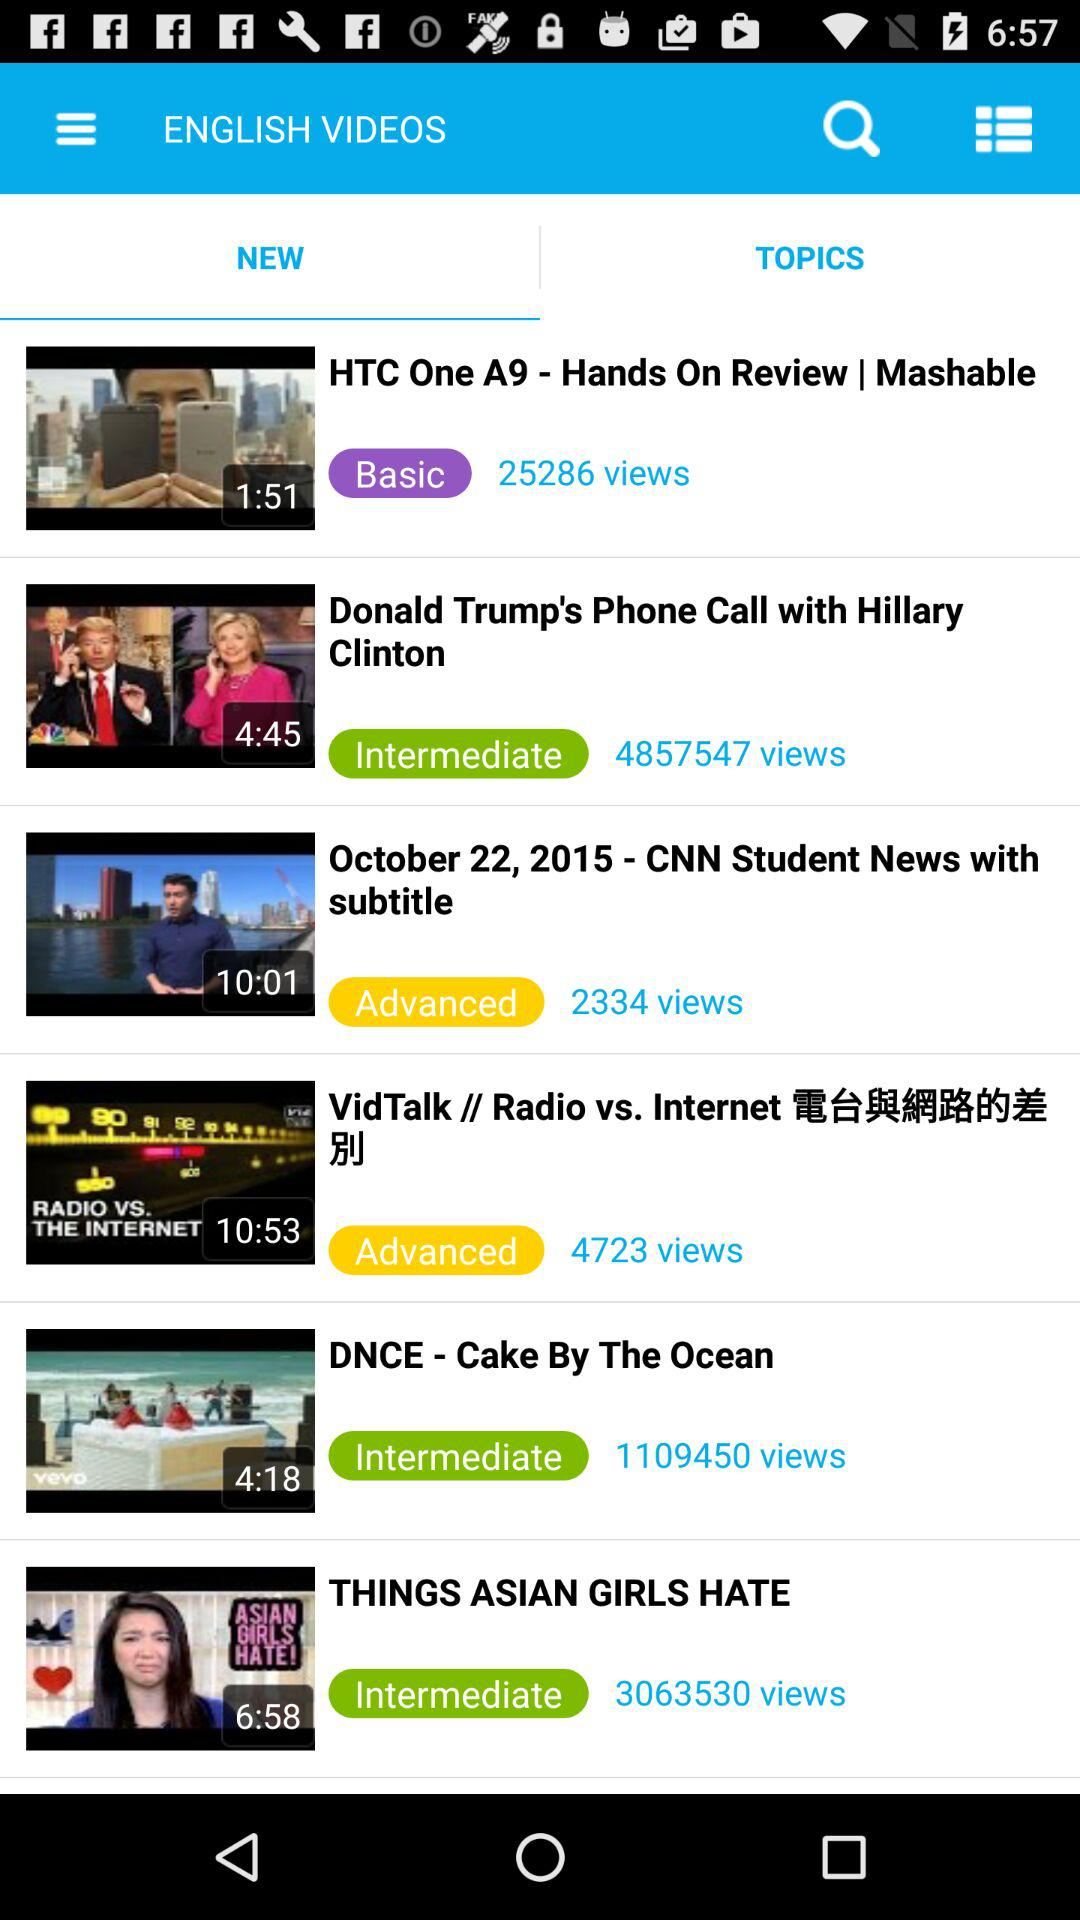How many video clips are there on this page?
Answer the question using a single word or phrase. 6 